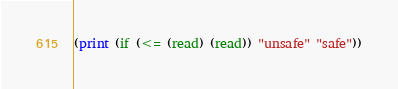<code> <loc_0><loc_0><loc_500><loc_500><_Scheme_>(print (if (<= (read) (read)) "unsafe" "safe"))</code> 